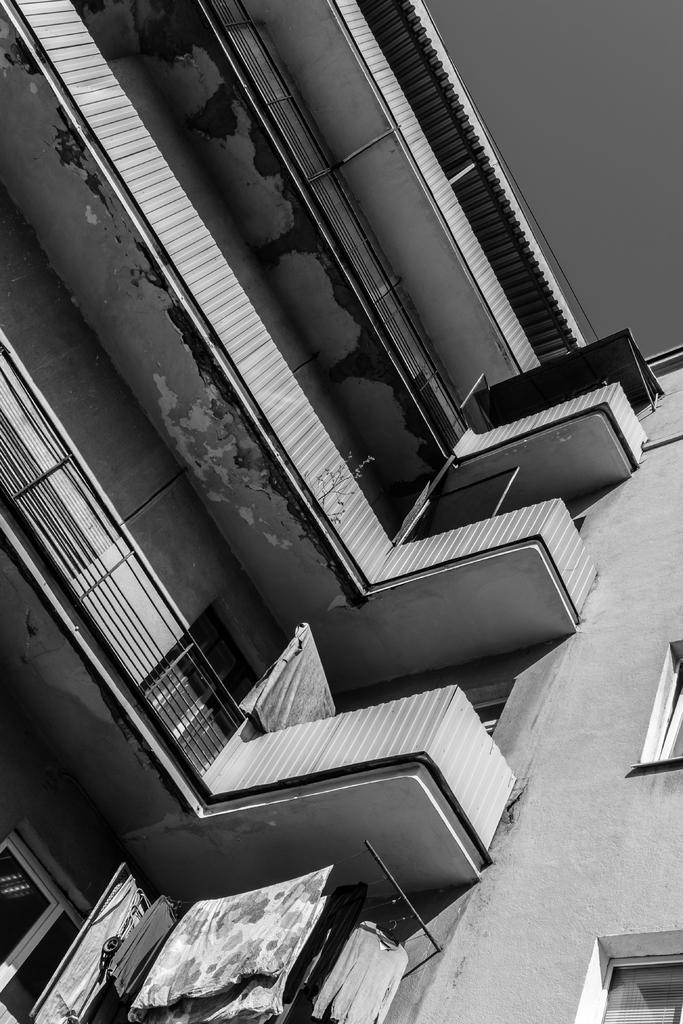What type of structure is visible in the image? There is a building in the image. What architectural feature can be seen on the building? There are balconies on the building. What activity is being performed with the clothes in the image? Clothes are hanging on ropes in the image. What type of writing can be seen on the building in the image? There is no writing visible on the building in the image. What kind of paste is being used to stick the clothes on the ropes in the image? There is no paste involved in hanging the clothes on the ropes in the image; they are simply tied or clipped to the ropes. 